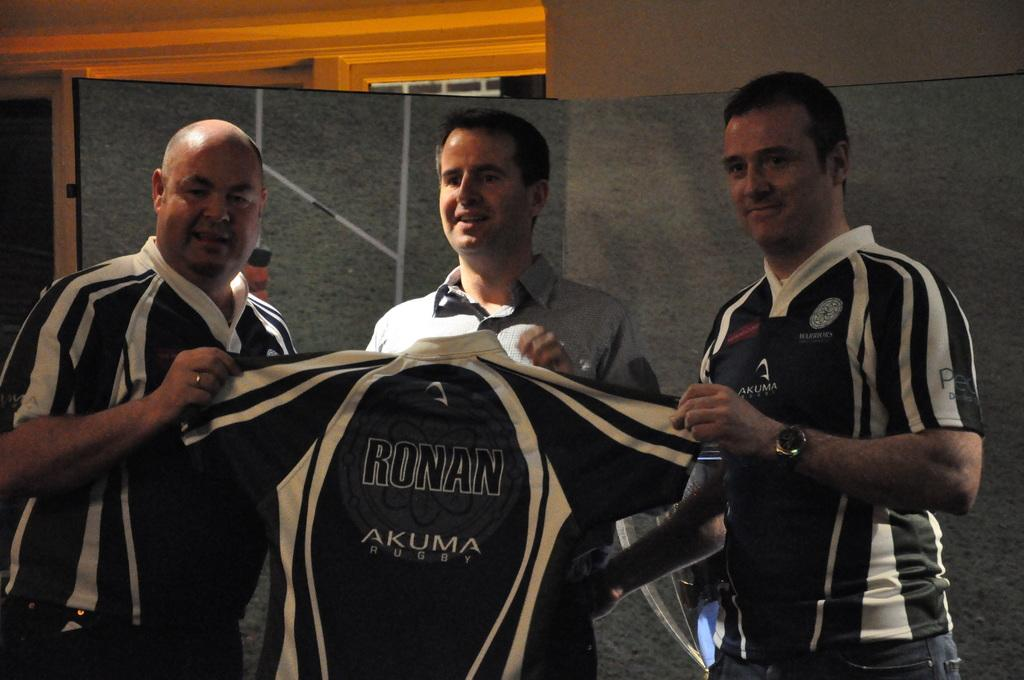Provide a one-sentence caption for the provided image. Three men hold a shirt bearing the words RONAN AKUMA QUEST on it. 